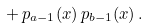Convert formula to latex. <formula><loc_0><loc_0><loc_500><loc_500>+ \, p _ { a - 1 } ( x ) \, p _ { b - 1 } ( x ) \, .</formula> 